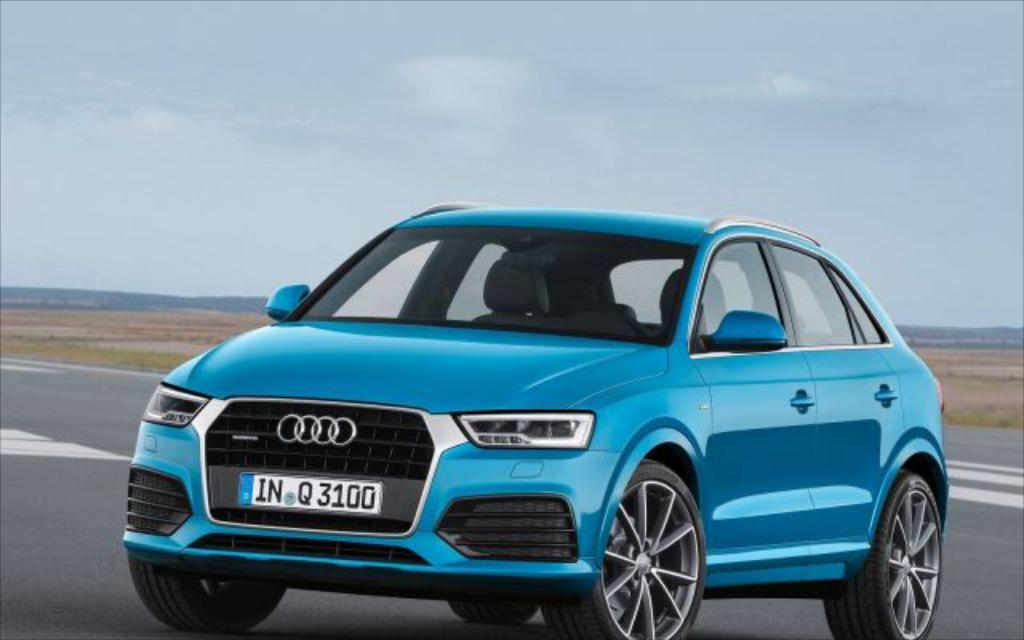What type of car is in the image? There is a blue Audi car in the image. What is a feature of the car that can be used for identification? The car has a number plate. What part of the car allows it to move? The car has wheels. Where is the car located in the image? The car is on the road. Can you see the driver's smile in the image? There is no driver visible in the image, so it is not possible to see their smile. 